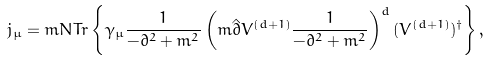<formula> <loc_0><loc_0><loc_500><loc_500>j _ { \mu } = m N T r \left \{ \gamma _ { \mu } \frac { 1 } { - \partial ^ { 2 } + m ^ { 2 } } \left ( m \hat { \partial } V ^ { ( d + 1 ) } \frac { 1 } { - \partial ^ { 2 } + m ^ { 2 } } \right ) ^ { d } ( V ^ { ( d + 1 ) } ) ^ { \dagger } \right \} ,</formula> 